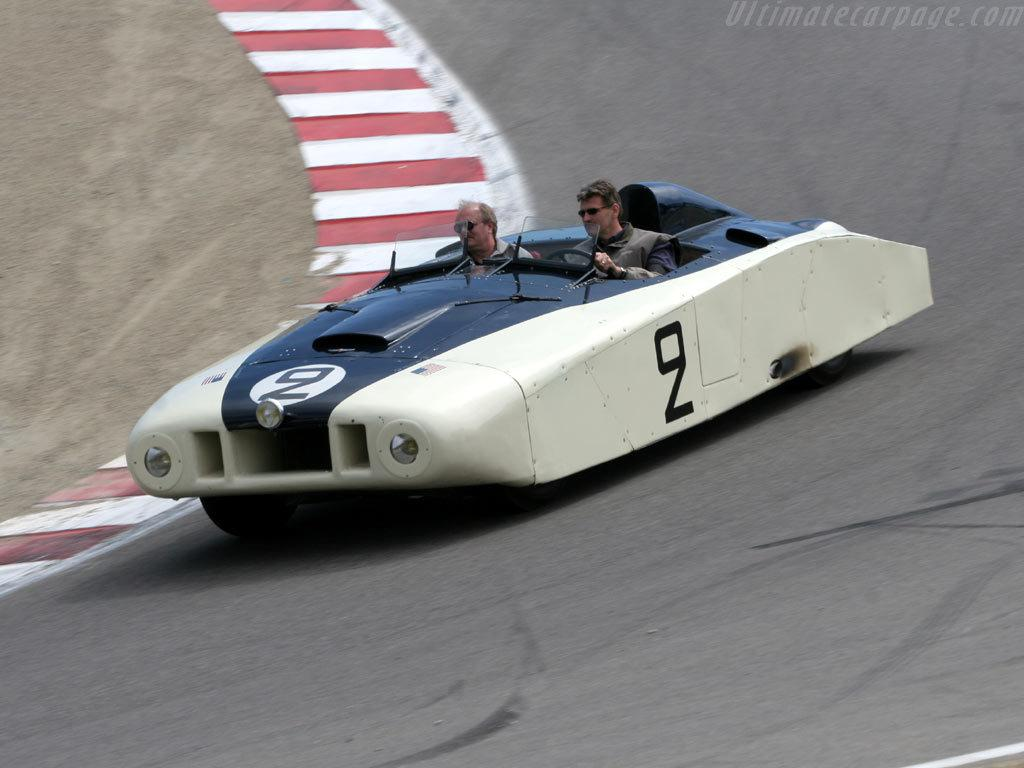What is the main subject of the image? There is a vehicle on the road in the image. Who is inside the vehicle? Two persons are sitting in the vehicle. Is there any additional information or marking on the image? Yes, there is a watermark in the top right corner of the image. What is the fifth route taken by the vehicle in the image? There is no information about the vehicle's route in the image, so it is not possible to determine the fifth route. 